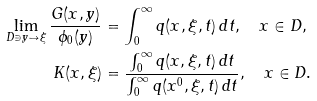<formula> <loc_0><loc_0><loc_500><loc_500>\lim _ { D \ni y \to \xi } \frac { G ( x , y ) } { \phi _ { 0 } ( y ) } & = \int _ { 0 } ^ { \infty } q ( x , \xi , t ) \, d t , \quad x \in D , \\ K ( x , \xi ) & = \frac { \int _ { 0 } ^ { \infty } q ( x , \xi , t ) \, d t } { \int _ { 0 } ^ { \infty } q ( x ^ { 0 } , \xi , t ) \, d t } , \quad x \in D .</formula> 